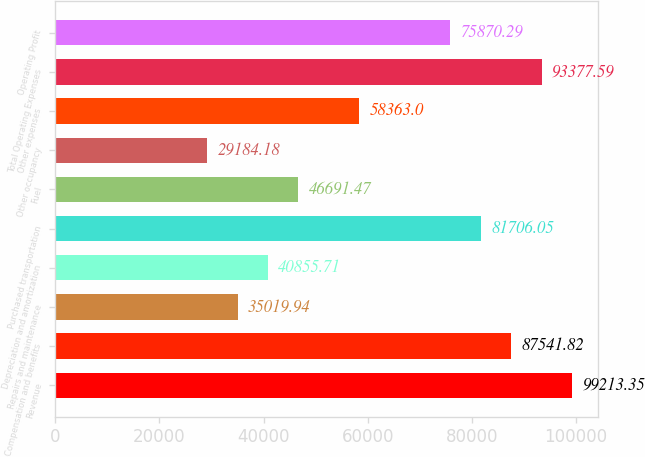<chart> <loc_0><loc_0><loc_500><loc_500><bar_chart><fcel>Revenue<fcel>Compensation and benefits<fcel>Repairs and maintenance<fcel>Depreciation and amortization<fcel>Purchased transportation<fcel>Fuel<fcel>Other occupancy<fcel>Other expenses<fcel>Total Operating Expenses<fcel>Operating Profit<nl><fcel>99213.4<fcel>87541.8<fcel>35019.9<fcel>40855.7<fcel>81706.1<fcel>46691.5<fcel>29184.2<fcel>58363<fcel>93377.6<fcel>75870.3<nl></chart> 